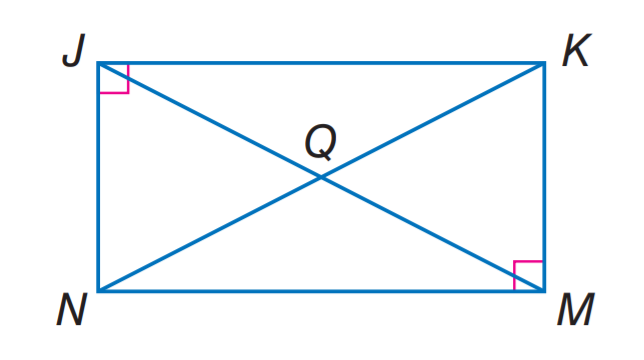Answer the mathemtical geometry problem and directly provide the correct option letter.
Question: J K M N is a rectangle. If N Q = 2 x + 3 and Q K = 5 x - 9, find J Q.
Choices: A: 4 B: 6 C: 9 D: 11 D 